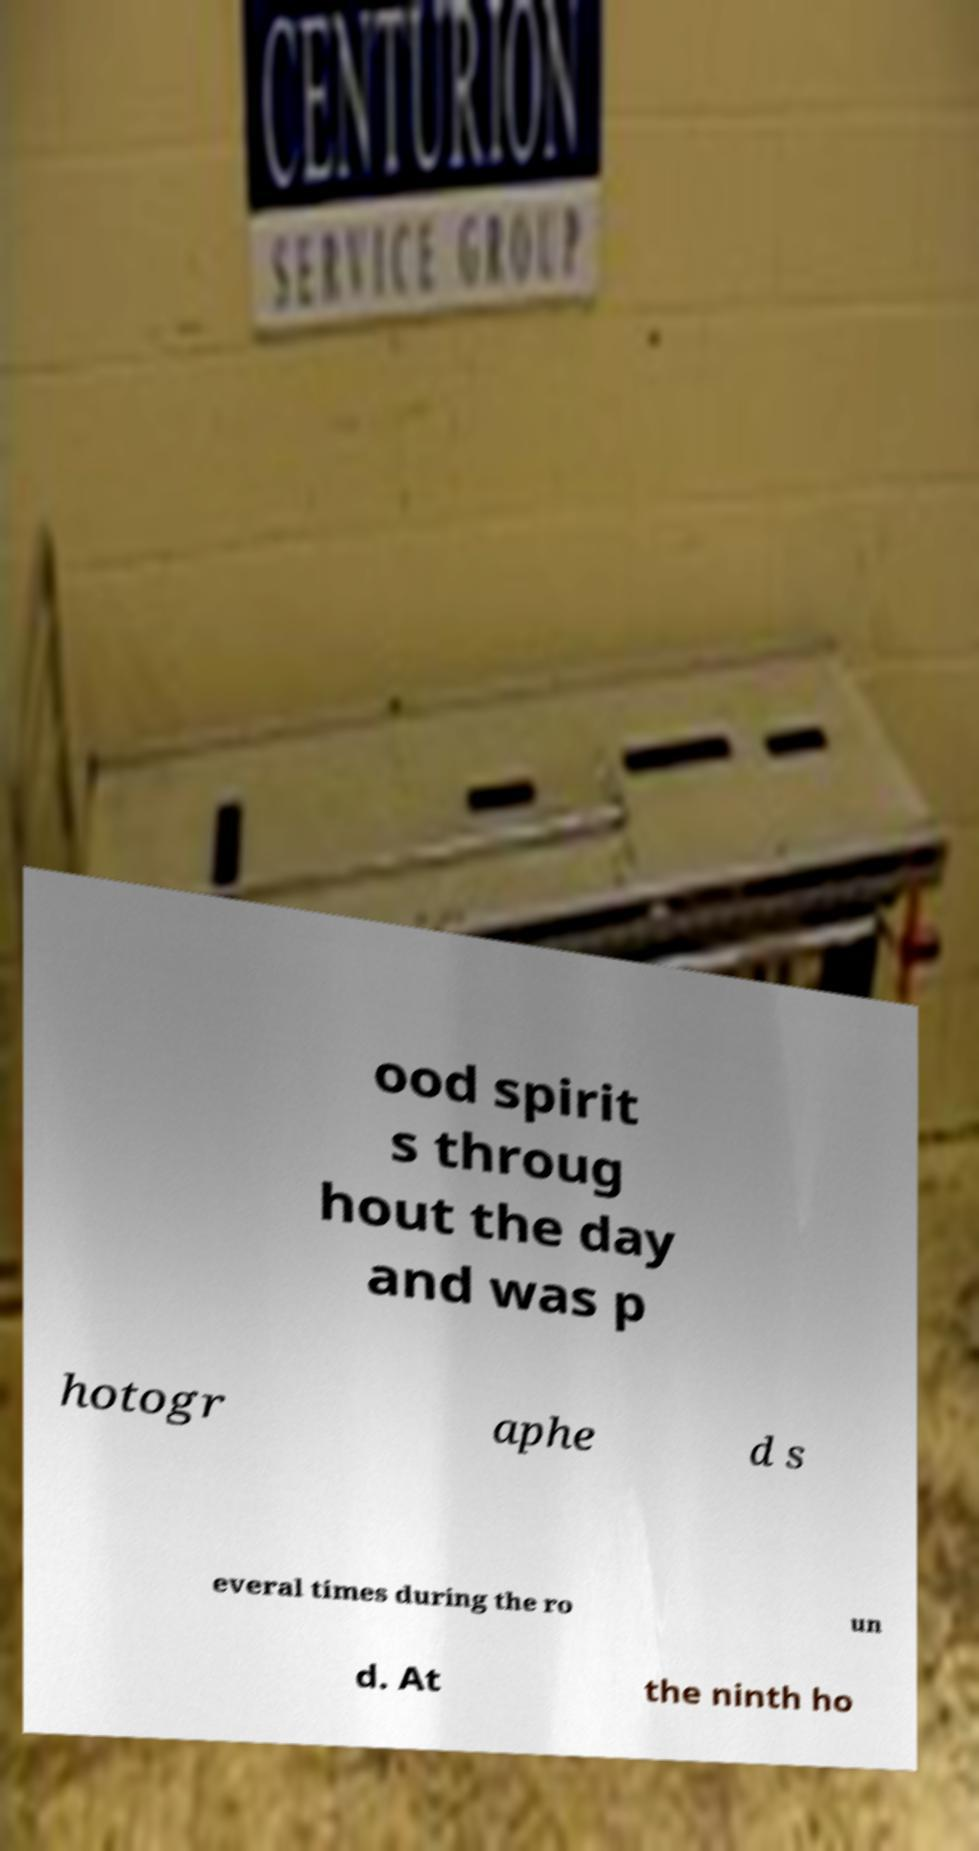Please read and relay the text visible in this image. What does it say? ood spirit s throug hout the day and was p hotogr aphe d s everal times during the ro un d. At the ninth ho 